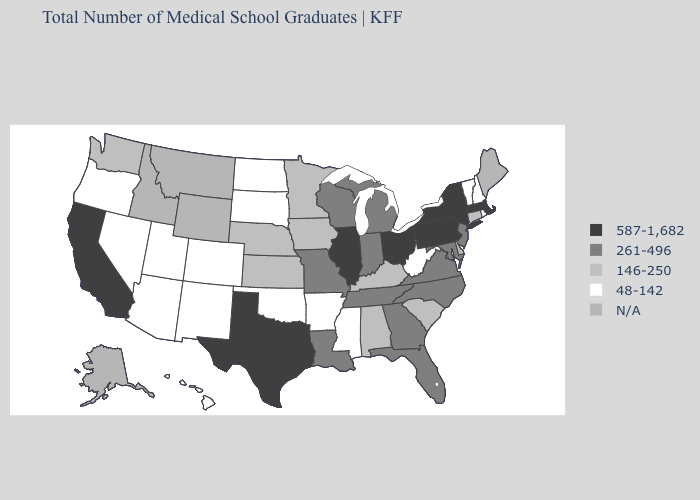Name the states that have a value in the range 261-496?
Quick response, please. Florida, Georgia, Indiana, Louisiana, Maryland, Michigan, Missouri, New Jersey, North Carolina, Tennessee, Virginia, Wisconsin. Among the states that border Maine , which have the lowest value?
Be succinct. New Hampshire. What is the value of Michigan?
Keep it brief. 261-496. Does Mississippi have the lowest value in the South?
Write a very short answer. Yes. What is the value of Hawaii?
Be succinct. 48-142. Which states hav the highest value in the South?
Short answer required. Texas. Name the states that have a value in the range N/A?
Be succinct. Alaska, Delaware, Idaho, Maine, Montana, Wyoming. Does Vermont have the highest value in the Northeast?
Short answer required. No. What is the value of Illinois?
Concise answer only. 587-1,682. Which states have the highest value in the USA?
Write a very short answer. California, Illinois, Massachusetts, New York, Ohio, Pennsylvania, Texas. Does Minnesota have the highest value in the USA?
Concise answer only. No. Name the states that have a value in the range 48-142?
Keep it brief. Arizona, Arkansas, Colorado, Hawaii, Mississippi, Nevada, New Hampshire, New Mexico, North Dakota, Oklahoma, Oregon, Rhode Island, South Dakota, Utah, Vermont, West Virginia. What is the value of Minnesota?
Answer briefly. 146-250. 